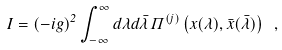<formula> <loc_0><loc_0><loc_500><loc_500>I = ( - i g ) ^ { 2 } \int _ { - \infty } ^ { \infty } d \lambda d \bar { \lambda } \, \Pi ^ { ( j ) } \left ( { x } ( \lambda ) , { \bar { x } } ( \bar { \lambda } ) \right ) \ ,</formula> 